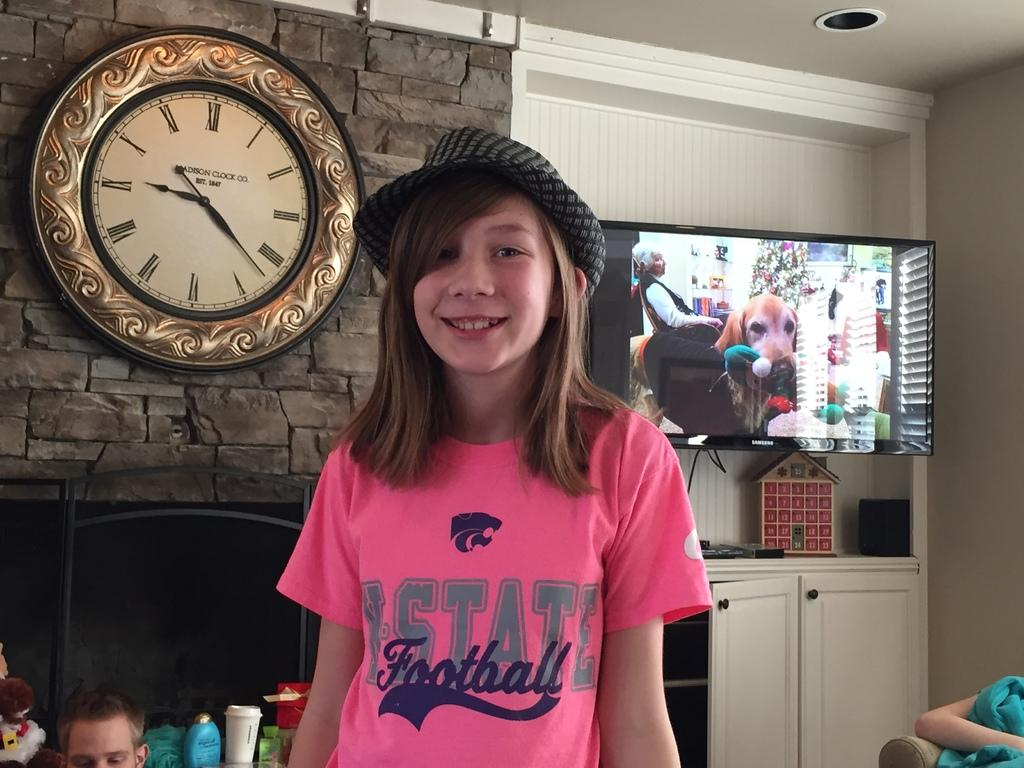<image>
Relay a brief, clear account of the picture shown. A girl wears a pink shirt that proclaims she is a football fan. 